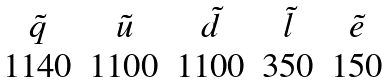Convert formula to latex. <formula><loc_0><loc_0><loc_500><loc_500>\begin{array} { c c c c c } \tilde { q } & \tilde { u } & \tilde { d } & \tilde { l } & \tilde { e } \\ 1 1 4 0 & 1 1 0 0 & 1 1 0 0 & 3 5 0 & 1 5 0 \end{array} \,</formula> 